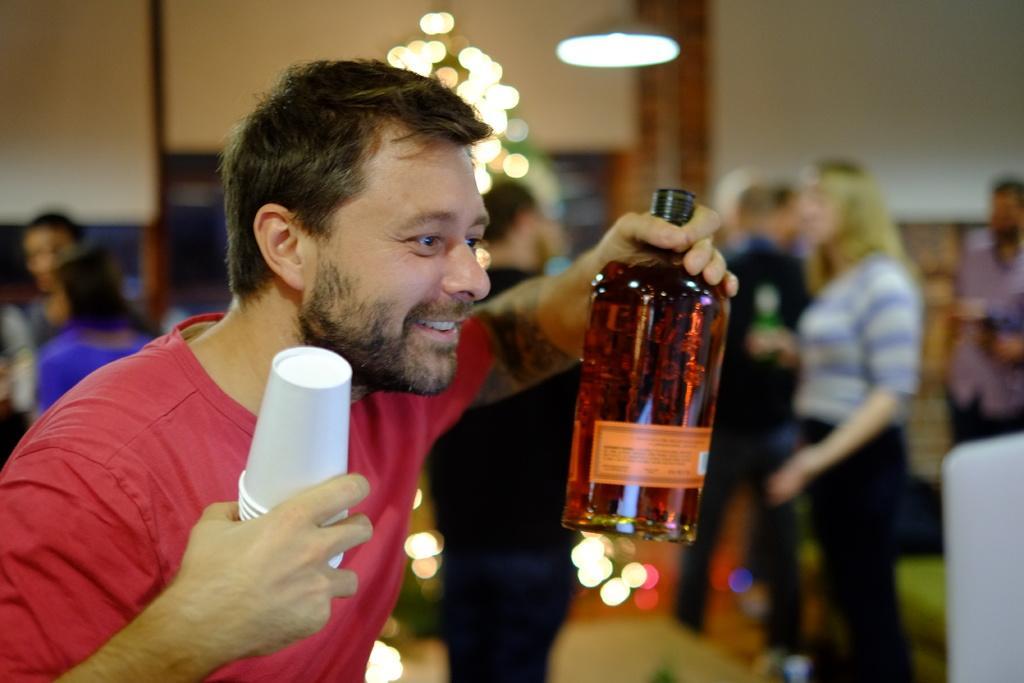Could you give a brief overview of what you see in this image? Here is a man holding a bottle and paper cups on his hands. At background I can see few people standing. 